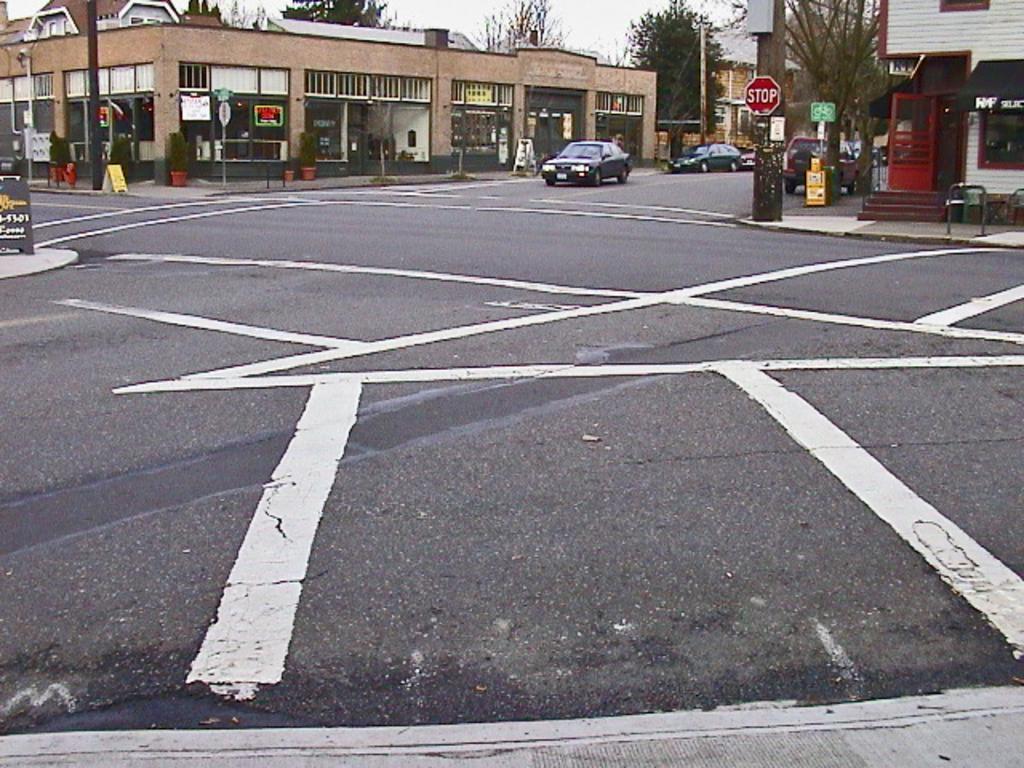Please provide a concise description of this image. In the center of the image we can see a few vehicles on the road. In the background, we can see the sky, trees, buildings, poles, sign boards, pots with plants and a few other objects. 